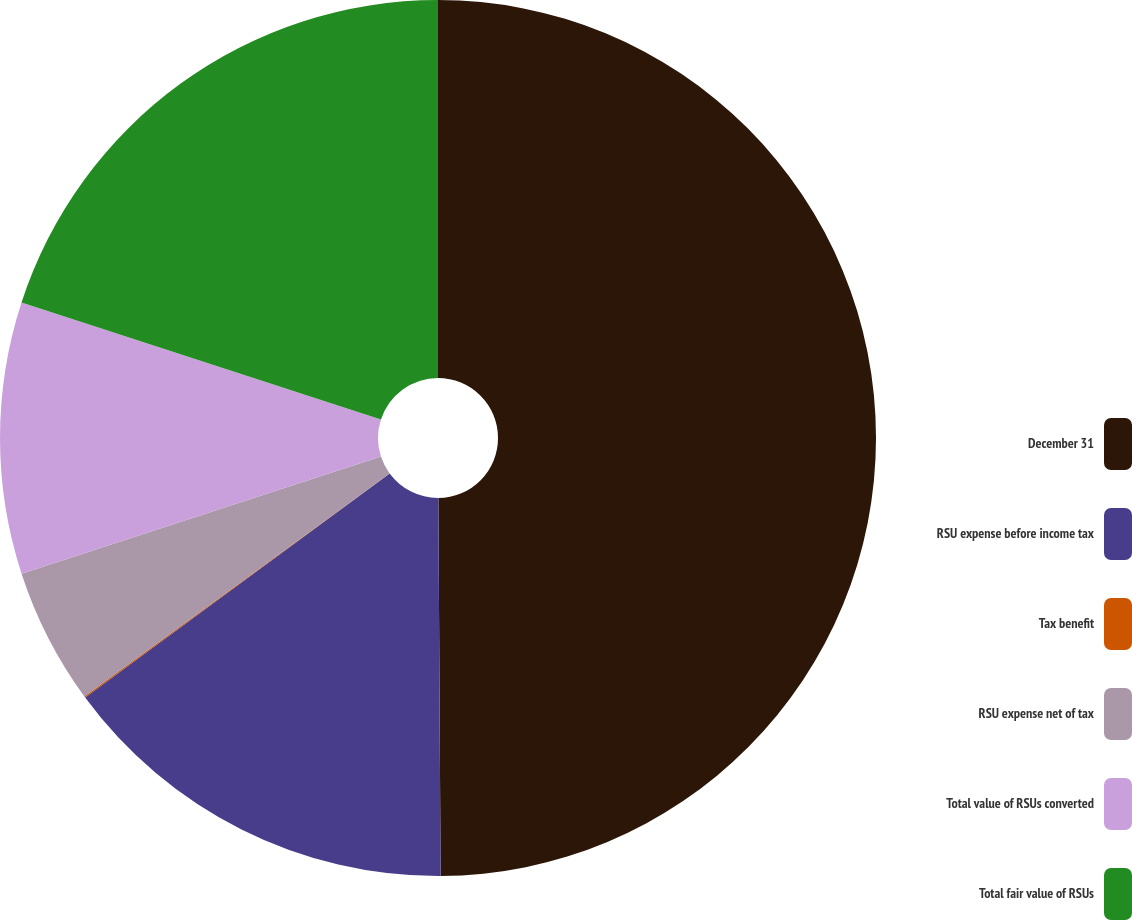<chart> <loc_0><loc_0><loc_500><loc_500><pie_chart><fcel>December 31<fcel>RSU expense before income tax<fcel>Tax benefit<fcel>RSU expense net of tax<fcel>Total value of RSUs converted<fcel>Total fair value of RSUs<nl><fcel>49.9%<fcel>15.0%<fcel>0.05%<fcel>5.03%<fcel>10.02%<fcel>19.99%<nl></chart> 